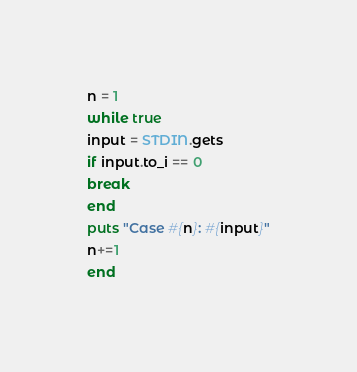<code> <loc_0><loc_0><loc_500><loc_500><_Ruby_>n = 1
while true
input = STDIN.gets
if input.to_i == 0
break
end
puts "Case #{n}: #{input}"
n+=1
end</code> 